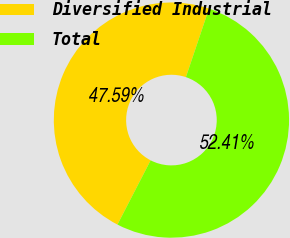Convert chart to OTSL. <chart><loc_0><loc_0><loc_500><loc_500><pie_chart><fcel>Diversified Industrial<fcel>Total<nl><fcel>47.59%<fcel>52.41%<nl></chart> 